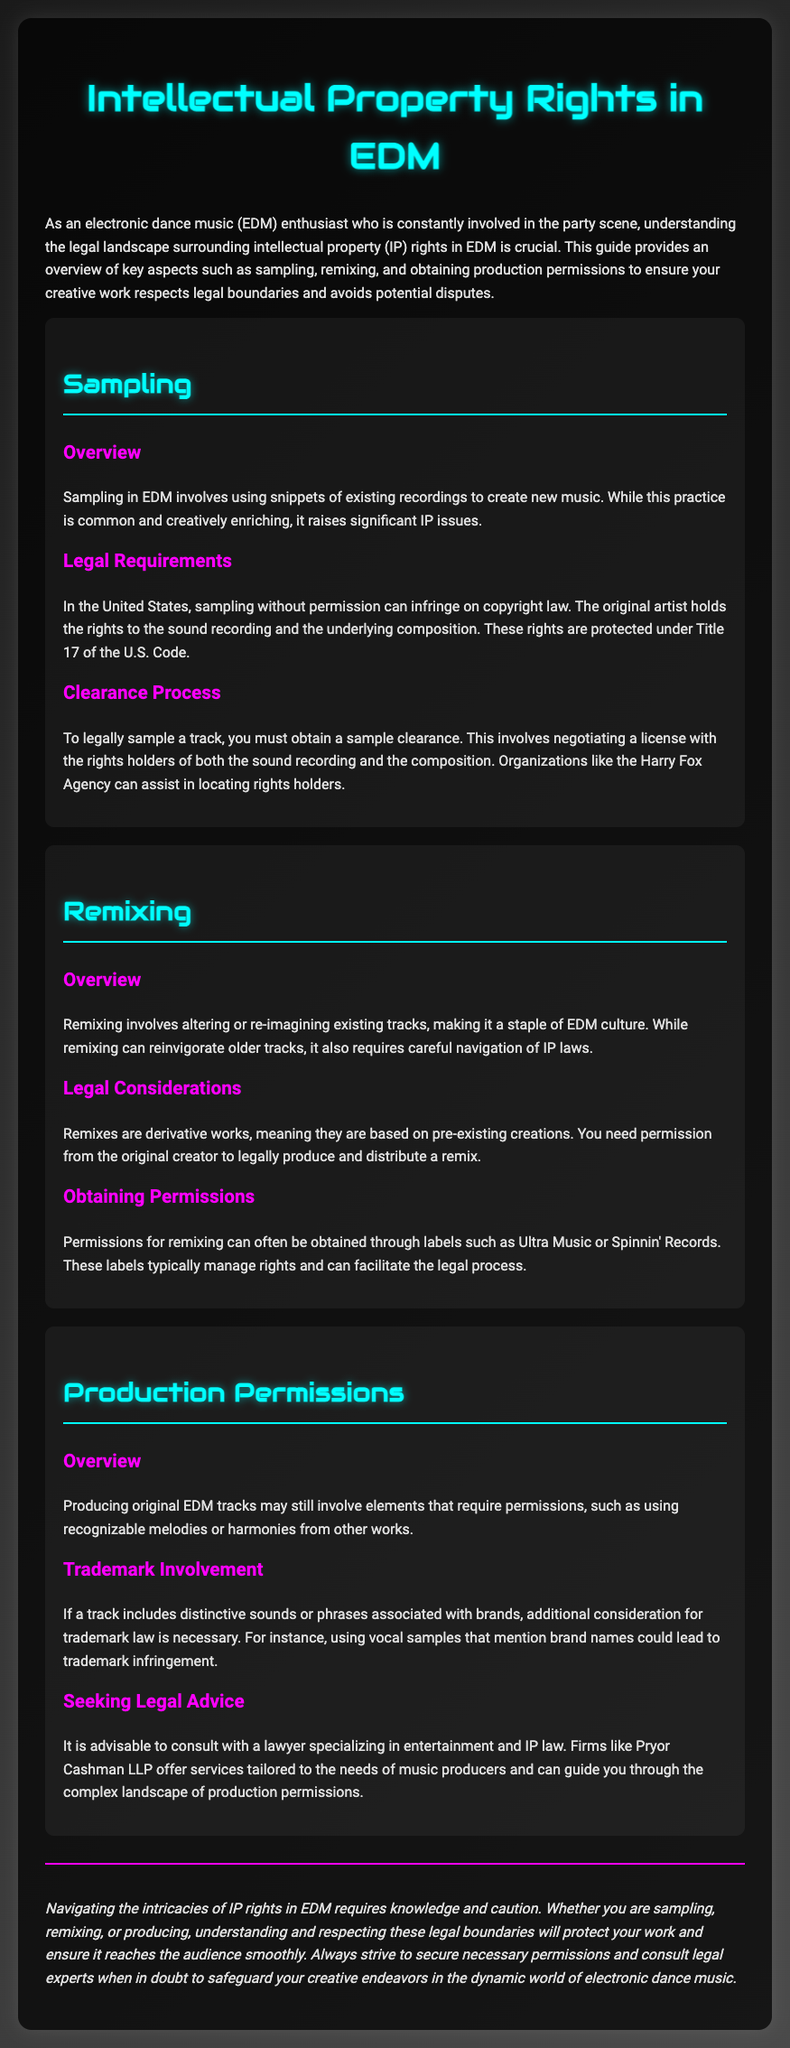what is the title of the document? The title appears prominently at the top of the rendered document, indicating the subject matter.
Answer: Intellectual Property Rights in EDM what legal title is referenced for sampling? The document mentions a specific title under U.S. law concerning sampling practices.
Answer: Title 17 who can assist in locating rights holders for sampling? The document identifies an organization that helps with sample clearance and rights holder identification.
Answer: Harry Fox Agency what is required to legally remix a track? The document specifies a crucial step necessary to create and distribute a remix legally.
Answer: Permission from the original creator which labels can permissions for remixing often be obtained from? The document lists specific labels known to manage rights for remixing within the EDM scene.
Answer: Ultra Music or Spinnin' Records what type of law should be considered if a track includes phrases associated with brands? The document refers to a legal consideration related to brand associations in music production.
Answer: Trademark law who should be consulted for advice on production permissions? The document recommends a specific type of professional for legal guidance on music production issues.
Answer: Lawyer specializing in entertainment and IP law what is the consequence of sampling without permission? The document mentions the legal implication associated with sampling without obtaining rights.
Answer: Copyright infringement what is the overall theme of the document? The document's introduction outlines the central focus and purpose of the content presented.
Answer: Intellectual property rights in EDM 